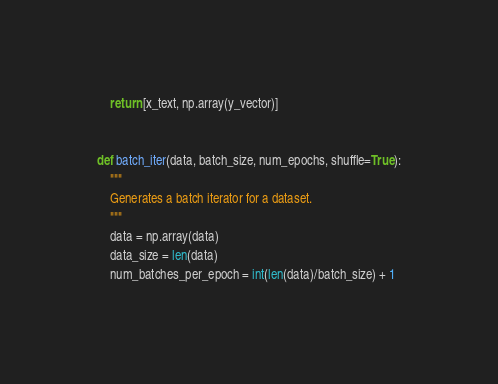<code> <loc_0><loc_0><loc_500><loc_500><_Python_>    return [x_text, np.array(y_vector)]


def batch_iter(data, batch_size, num_epochs, shuffle=True):
    """
    Generates a batch iterator for a dataset.
    """
    data = np.array(data)
    data_size = len(data)
    num_batches_per_epoch = int(len(data)/batch_size) + 1</code> 